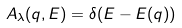<formula> <loc_0><loc_0><loc_500><loc_500>A _ { \lambda } ( { q } , E ) = \delta ( E - E ( { q } ) )</formula> 